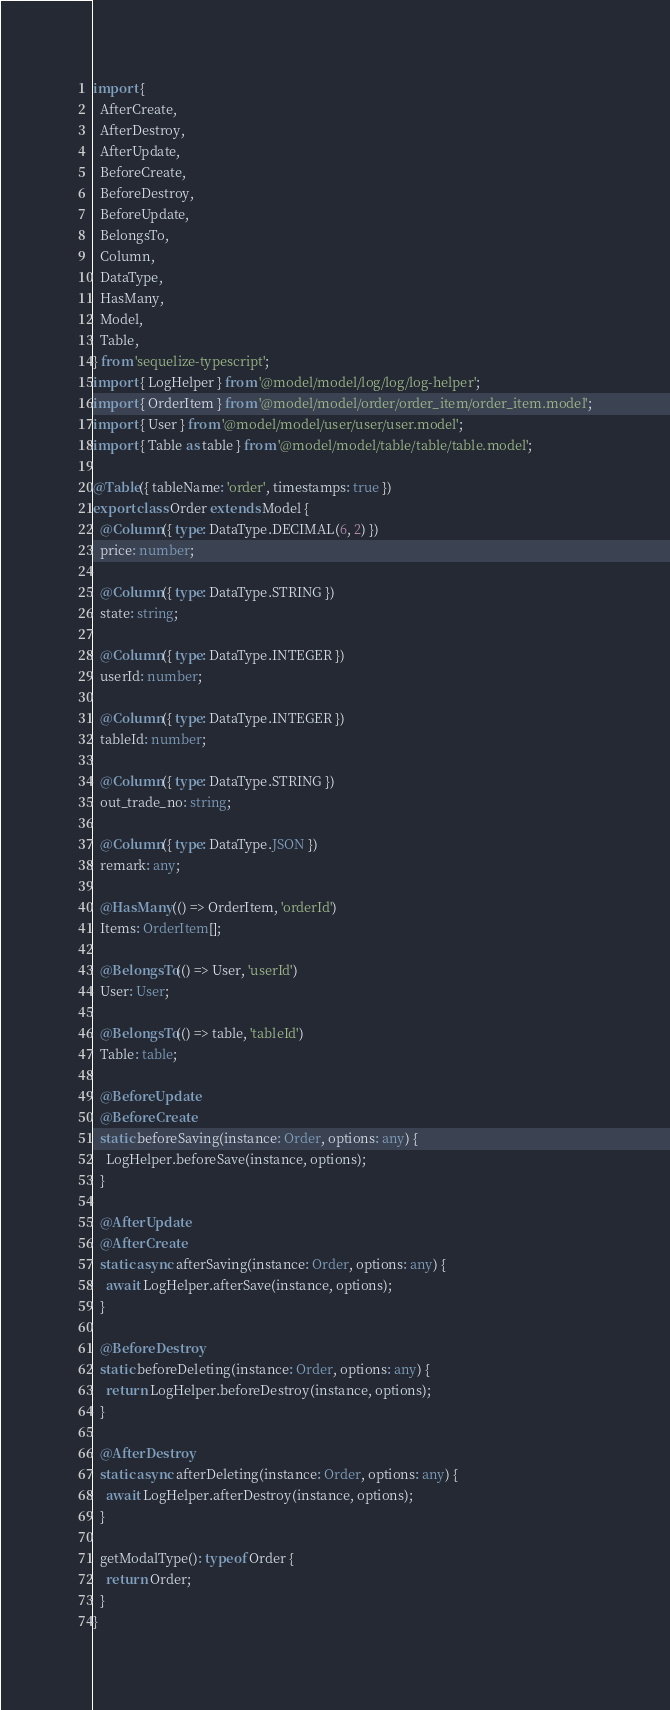Convert code to text. <code><loc_0><loc_0><loc_500><loc_500><_TypeScript_>import {
  AfterCreate,
  AfterDestroy,
  AfterUpdate,
  BeforeCreate,
  BeforeDestroy,
  BeforeUpdate,
  BelongsTo,
  Column,
  DataType,
  HasMany,
  Model,
  Table,
} from 'sequelize-typescript';
import { LogHelper } from '@model/model/log/log/log-helper';
import { OrderItem } from '@model/model/order/order_item/order_item.model';
import { User } from '@model/model/user/user/user.model';
import { Table as table } from '@model/model/table/table/table.model';

@Table({ tableName: 'order', timestamps: true })
export class Order extends Model {
  @Column({ type: DataType.DECIMAL(6, 2) })
  price: number;

  @Column({ type: DataType.STRING })
  state: string;

  @Column({ type: DataType.INTEGER })
  userId: number;

  @Column({ type: DataType.INTEGER })
  tableId: number;

  @Column({ type: DataType.STRING })
  out_trade_no: string;

  @Column({ type: DataType.JSON })
  remark: any;

  @HasMany(() => OrderItem, 'orderId')
  Items: OrderItem[];

  @BelongsTo(() => User, 'userId')
  User: User;

  @BelongsTo(() => table, 'tableId')
  Table: table;

  @BeforeUpdate
  @BeforeCreate
  static beforeSaving(instance: Order, options: any) {
    LogHelper.beforeSave(instance, options);
  }

  @AfterUpdate
  @AfterCreate
  static async afterSaving(instance: Order, options: any) {
    await LogHelper.afterSave(instance, options);
  }

  @BeforeDestroy
  static beforeDeleting(instance: Order, options: any) {
    return LogHelper.beforeDestroy(instance, options);
  }

  @AfterDestroy
  static async afterDeleting(instance: Order, options: any) {
    await LogHelper.afterDestroy(instance, options);
  }

  getModalType(): typeof Order {
    return Order;
  }
}
</code> 